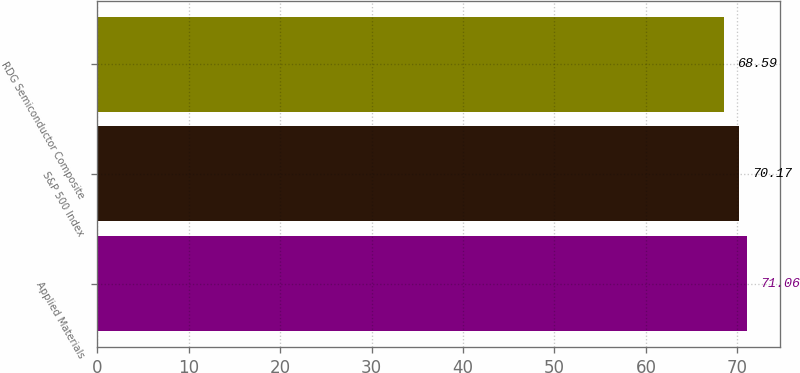<chart> <loc_0><loc_0><loc_500><loc_500><bar_chart><fcel>Applied Materials<fcel>S&P 500 Index<fcel>RDG Semiconductor Composite<nl><fcel>71.06<fcel>70.17<fcel>68.59<nl></chart> 